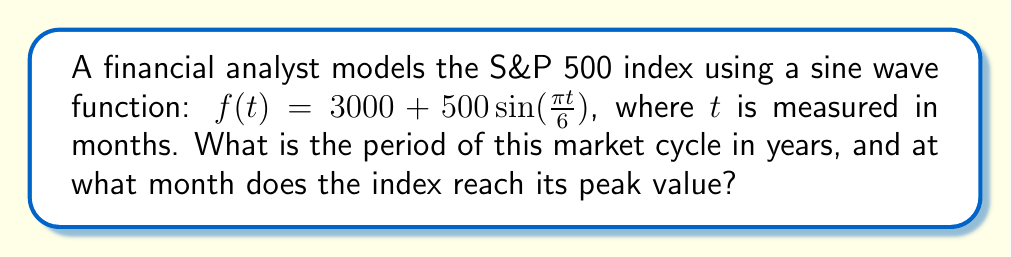Solve this math problem. Let's approach this step-by-step:

1) The general form of a sine function is:
   $f(t) = A\sin(Bt) + C$
   Where $\frac{2\pi}{B}$ is the period, $A$ is the amplitude, and $C$ is the vertical shift.

2) In our case:
   $f(t) = 500\sin(\frac{\pi t}{6}) + 3000$

3) To find the period, we need to solve:
   $\frac{2\pi}{B} = \frac{2\pi}{\frac{\pi}{6}} = 12$ months

4) Converting to years:
   $12$ months $= 1$ year

5) To find the peak, we need to find when $\sin(\frac{\pi t}{6})$ equals 1.
   This occurs when $\frac{\pi t}{6} = \frac{\pi}{2}$

6) Solving for $t$:
   $t = \frac{6 \cdot \frac{\pi}{2}}{\pi} = 3$ months

Therefore, the period is 1 year, and the peak occurs at 3 months.
Answer: 1 year; 3 months 